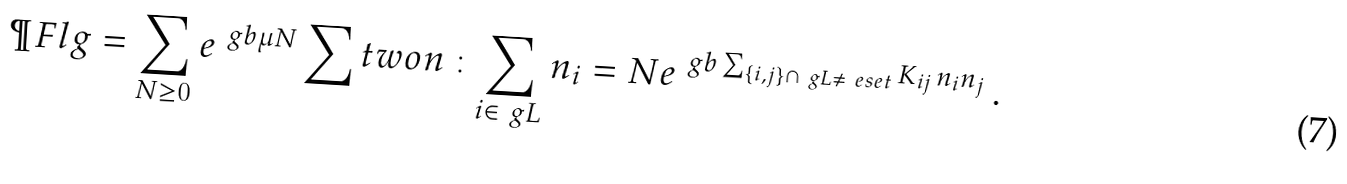<formula> <loc_0><loc_0><loc_500><loc_500>\P F l g = \sum _ { N \geq 0 } e ^ { \ g b \mu N } \sum t w o { n \, \colon } { \sum _ { i \in \ g L } n _ { i } = N } e ^ { \ g b \sum _ { \{ i , j \} \cap \ g L \neq \ e s e t } K _ { i j } \, n _ { i } n _ { j } } \, .</formula> 